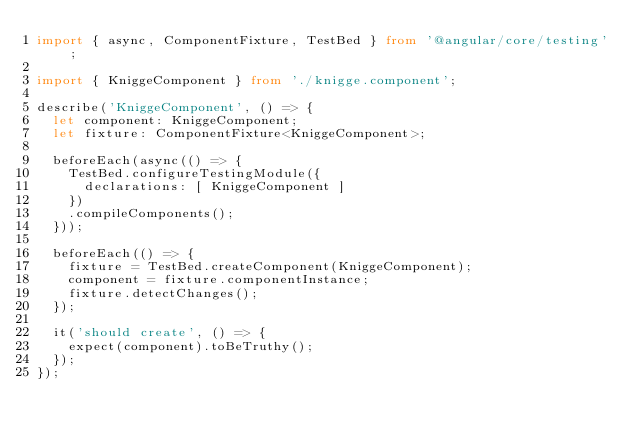Convert code to text. <code><loc_0><loc_0><loc_500><loc_500><_TypeScript_>import { async, ComponentFixture, TestBed } from '@angular/core/testing';

import { KniggeComponent } from './knigge.component';

describe('KniggeComponent', () => {
  let component: KniggeComponent;
  let fixture: ComponentFixture<KniggeComponent>;

  beforeEach(async(() => {
    TestBed.configureTestingModule({
      declarations: [ KniggeComponent ]
    })
    .compileComponents();
  }));

  beforeEach(() => {
    fixture = TestBed.createComponent(KniggeComponent);
    component = fixture.componentInstance;
    fixture.detectChanges();
  });

  it('should create', () => {
    expect(component).toBeTruthy();
  });
});
</code> 